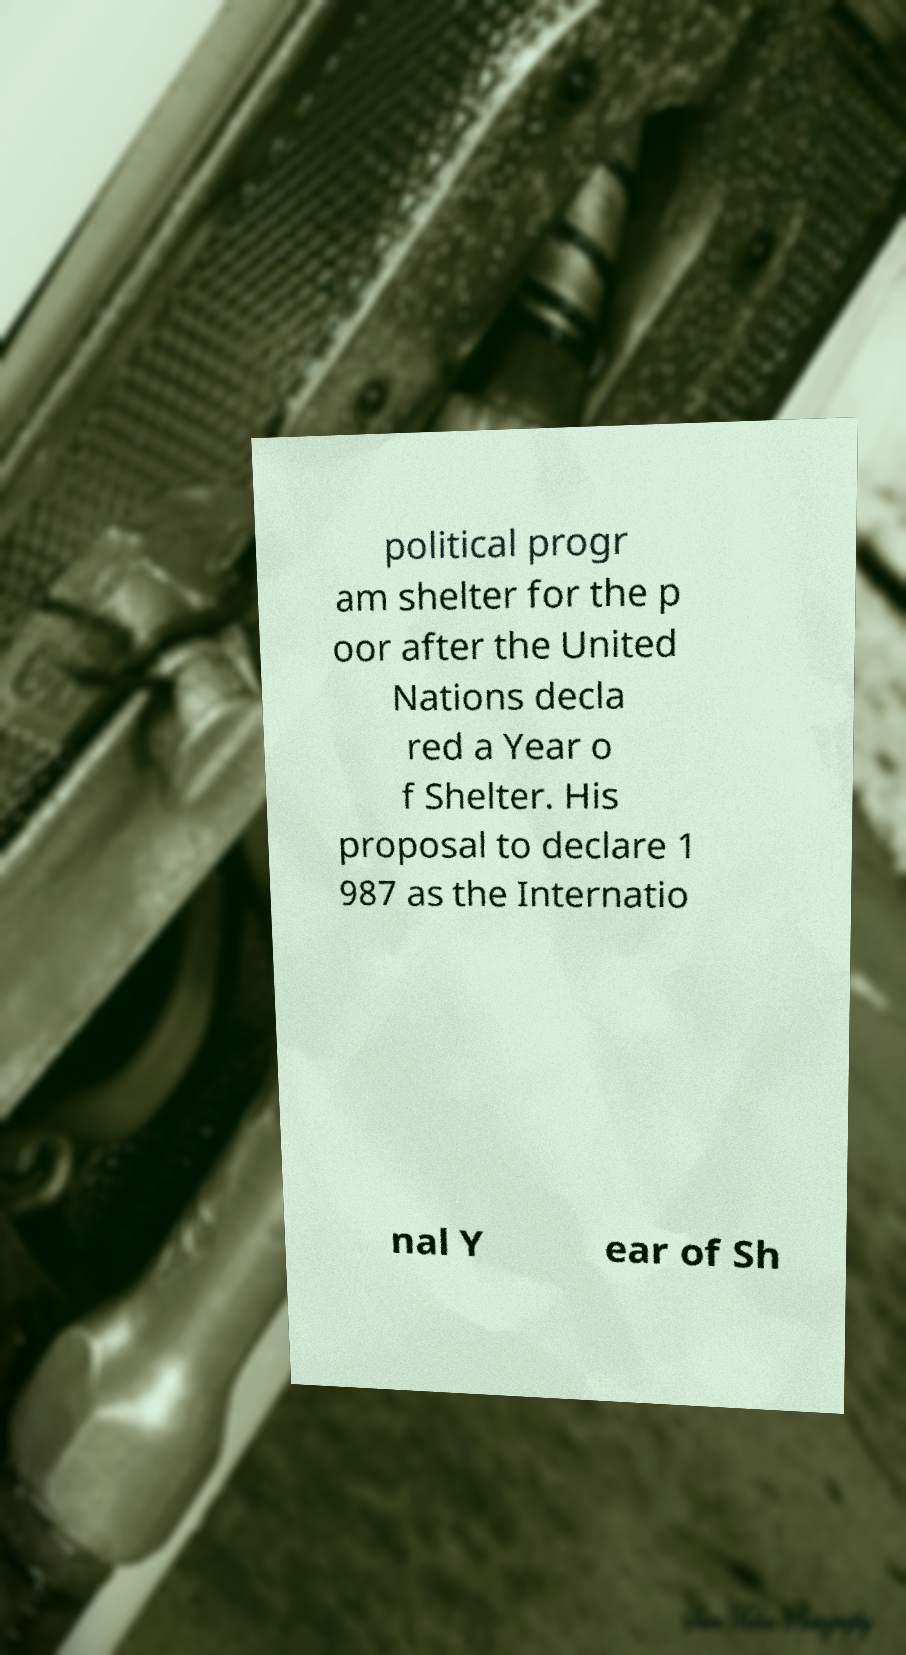Can you accurately transcribe the text from the provided image for me? political progr am shelter for the p oor after the United Nations decla red a Year o f Shelter. His proposal to declare 1 987 as the Internatio nal Y ear of Sh 